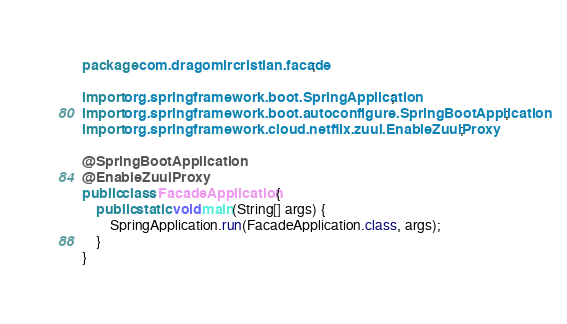<code> <loc_0><loc_0><loc_500><loc_500><_Java_>package com.dragomircristian.facade;

import org.springframework.boot.SpringApplication;
import org.springframework.boot.autoconfigure.SpringBootApplication;
import org.springframework.cloud.netflix.zuul.EnableZuulProxy;

@SpringBootApplication
@EnableZuulProxy
public class FacadeApplication {
    public static void main(String[] args) {
        SpringApplication.run(FacadeApplication.class, args);
    }
}
</code> 